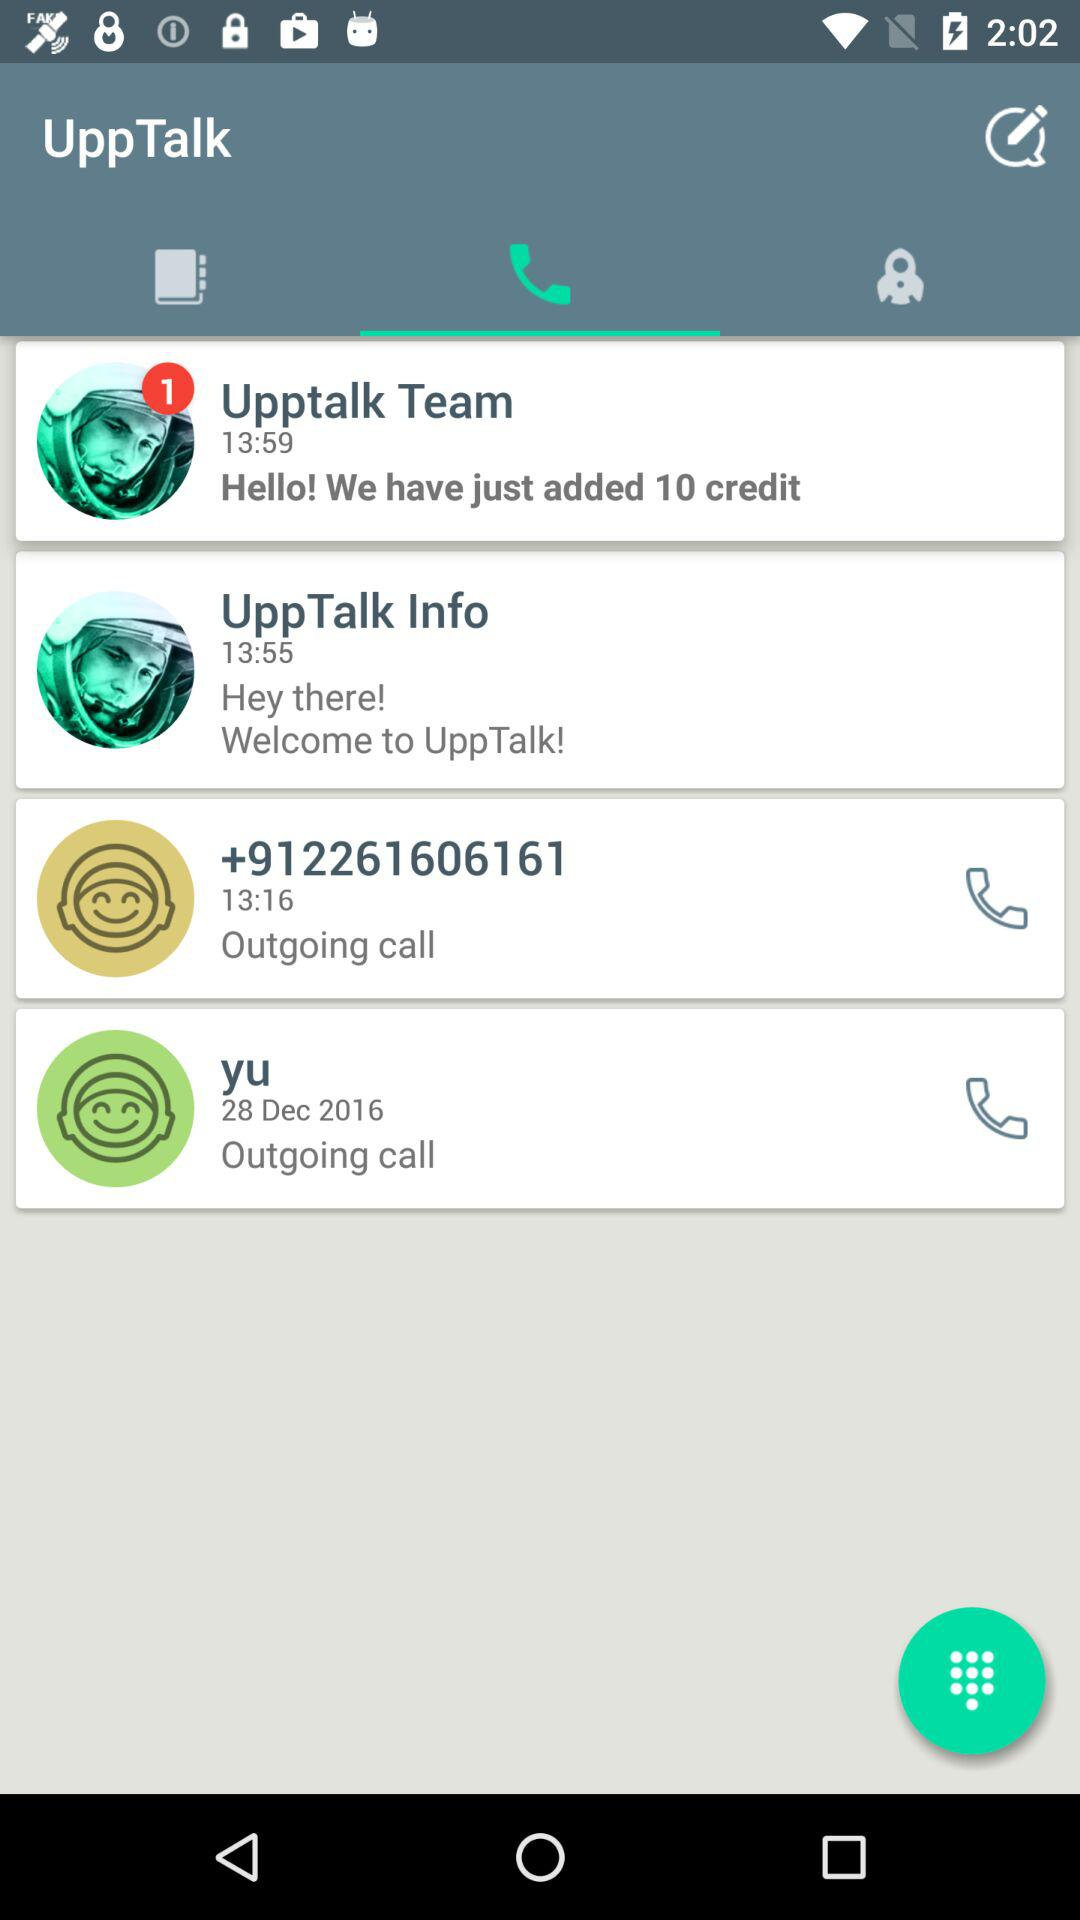When did I call Yu? You called Yu on December 28, 2016. 